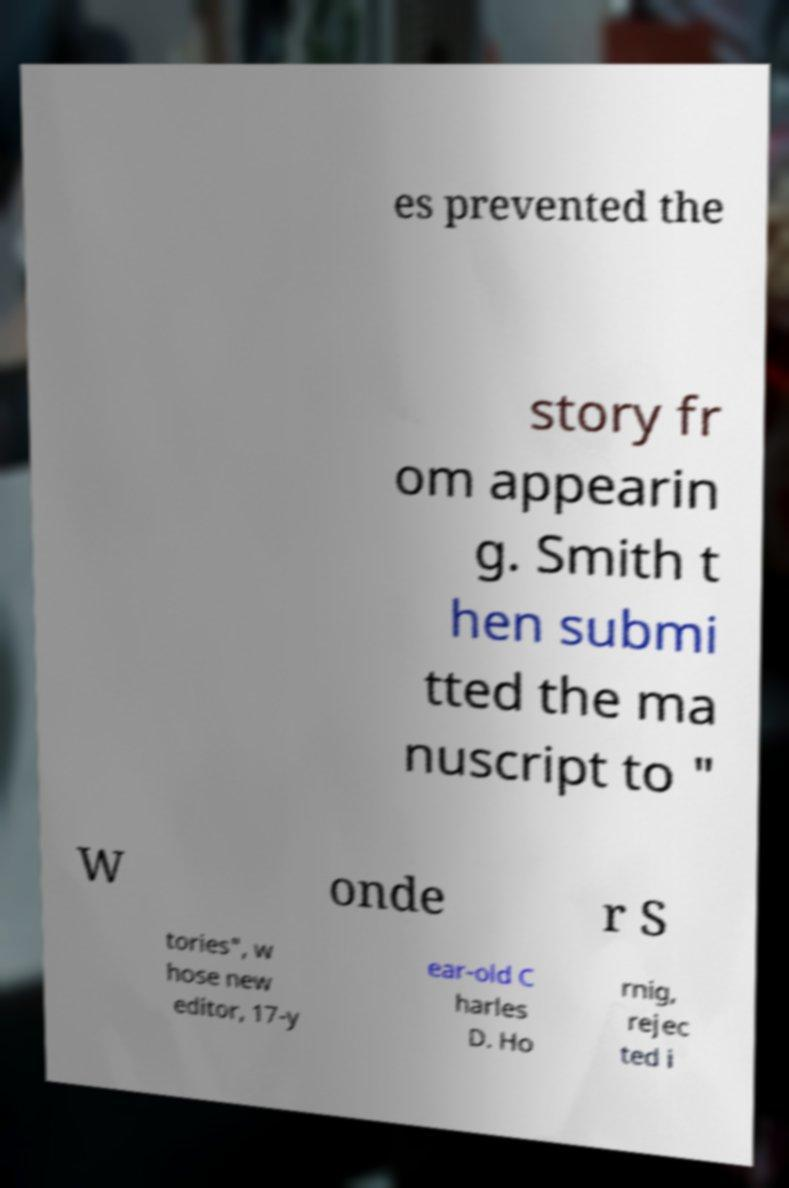Please identify and transcribe the text found in this image. es prevented the story fr om appearin g. Smith t hen submi tted the ma nuscript to " W onde r S tories", w hose new editor, 17-y ear-old C harles D. Ho rnig, rejec ted i 